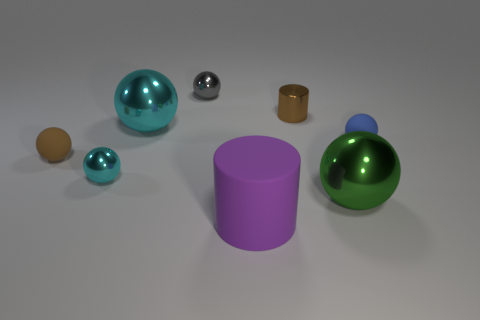What number of objects are yellow things or things?
Offer a terse response. 8. There is a small metal sphere in front of the brown cylinder; what number of small cyan metallic objects are behind it?
Ensure brevity in your answer.  0. What number of other things are the same size as the brown sphere?
Your answer should be compact. 4. What is the size of the matte sphere that is the same color as the metallic cylinder?
Your answer should be compact. Small. Is the shape of the tiny rubber thing on the right side of the large green object the same as  the large green thing?
Provide a short and direct response. Yes. What is the small ball that is right of the matte cylinder made of?
Your answer should be compact. Rubber. What is the shape of the object that is the same color as the tiny cylinder?
Ensure brevity in your answer.  Sphere. Are there any blocks that have the same material as the blue object?
Offer a terse response. No. How big is the green metallic sphere?
Offer a very short reply. Large. How many brown things are either tiny shiny things or balls?
Offer a very short reply. 2. 